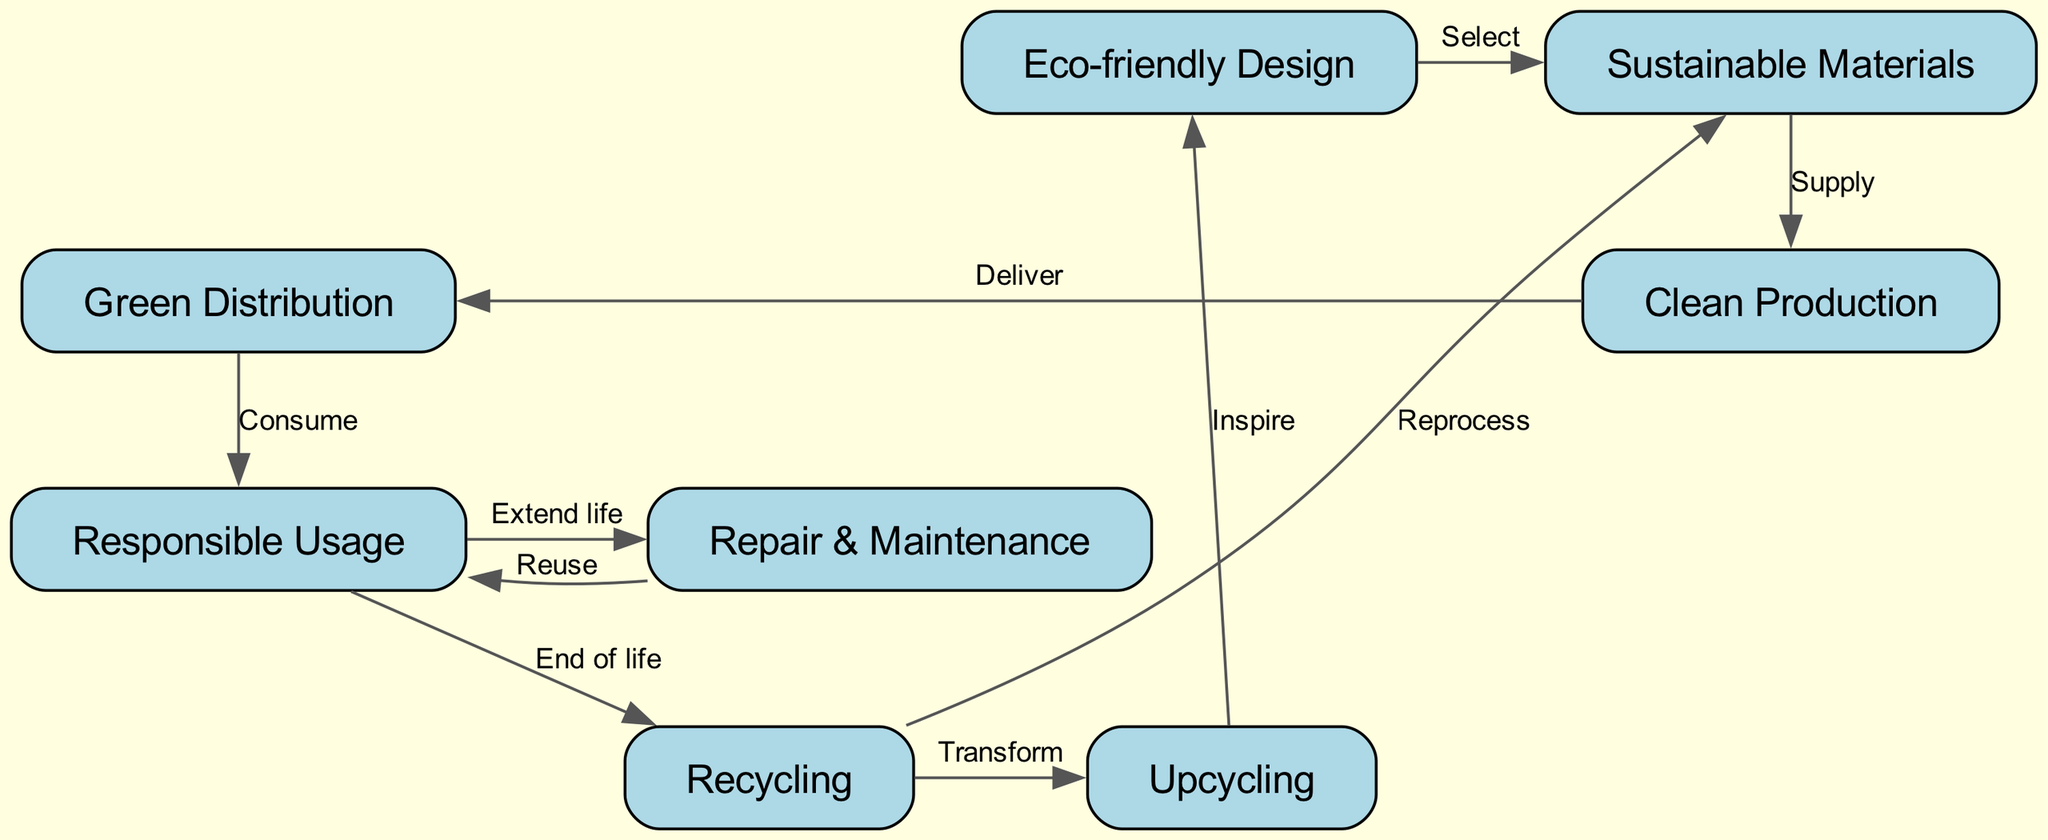What's the total number of nodes in the diagram? The diagram lists eight distinct nodes, which represent various stages in the circular economy model for sustainable product lifecycle.
Answer: Eight Which node comes immediately after "Sustainable Materials"? The diagram shows an edge labeled "Supply" that connects "Sustainable Materials" to "Clean Production," indicating that "Clean Production" follows "Sustainable Materials".
Answer: Clean Production What is the relationship between "Responsible Usage" and "Repair & Maintenance"? According to the diagram, "Responsible Usage" leads to "Repair & Maintenance" through the edge labeled "Extend life," establishing a direct relationship where responsible usage facilitates repair and maintenance activities.
Answer: Extend life How many edges are there in total? By counting the connections between the nodes, there are ten edges that illustrate the relationships between the various stages of the circular economy model in the diagram.
Answer: Ten What is the final outcome of "Recycle"? The edges leading out of "Recycle" show that it connects to both "Sustainable Materials" and "Upcycling," indicating that the end process of recycling can either regenerate materials or lead to upcycling processes.
Answer: Upcycling, Sustainable Materials Which node inspires new designs? The diagram indicates that "Upcycling" inspires new designs, evidenced by the edge labeled "Inspire" that connects "Upcycling" back to "Eco-friendly Design."
Answer: Eco-friendly Design What is the primary function of the node "Clean Production"? The node "Clean Production" is responsible for receiving materials, as indicated by the "Supply" edge coming from "Sustainable Materials," outlining its role in the production phase of the product lifecycle.
Answer: Supply How does "Usage" affect "Recycle"? The diagram shows that "Usage" leads to "Recycle" via the edge labeled "End of life," which suggests that responsible usage directly impacts the recycling process at the conclusion of a product's lifecycle.
Answer: End of life What action is taken after "Repair & Maintenance"? After "Repair & Maintenance," the diagram indicates that the next action is "Reuse," as shown by the edge connecting these two nodes, signifying that maintenance activities allow the product to be reused.
Answer: Reuse 